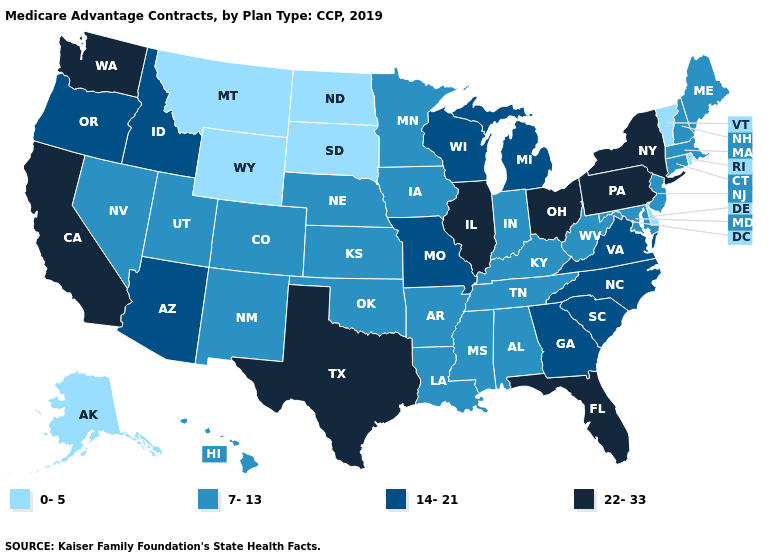Does South Dakota have the lowest value in the MidWest?
Short answer required. Yes. What is the highest value in the South ?
Keep it brief. 22-33. Name the states that have a value in the range 22-33?
Short answer required. California, Florida, Illinois, New York, Ohio, Pennsylvania, Texas, Washington. Among the states that border Utah , which have the lowest value?
Keep it brief. Wyoming. Name the states that have a value in the range 0-5?
Answer briefly. Alaska, Delaware, Montana, North Dakota, Rhode Island, South Dakota, Vermont, Wyoming. Which states have the highest value in the USA?
Keep it brief. California, Florida, Illinois, New York, Ohio, Pennsylvania, Texas, Washington. What is the highest value in states that border Oregon?
Answer briefly. 22-33. What is the lowest value in the USA?
Write a very short answer. 0-5. Name the states that have a value in the range 0-5?
Concise answer only. Alaska, Delaware, Montana, North Dakota, Rhode Island, South Dakota, Vermont, Wyoming. Name the states that have a value in the range 7-13?
Give a very brief answer. Alabama, Arkansas, Colorado, Connecticut, Hawaii, Indiana, Iowa, Kansas, Kentucky, Louisiana, Maine, Maryland, Massachusetts, Minnesota, Mississippi, Nebraska, Nevada, New Hampshire, New Jersey, New Mexico, Oklahoma, Tennessee, Utah, West Virginia. Name the states that have a value in the range 22-33?
Write a very short answer. California, Florida, Illinois, New York, Ohio, Pennsylvania, Texas, Washington. Which states have the lowest value in the USA?
Quick response, please. Alaska, Delaware, Montana, North Dakota, Rhode Island, South Dakota, Vermont, Wyoming. What is the value of Oregon?
Answer briefly. 14-21. Which states have the lowest value in the Northeast?
Answer briefly. Rhode Island, Vermont. What is the value of Michigan?
Be succinct. 14-21. 